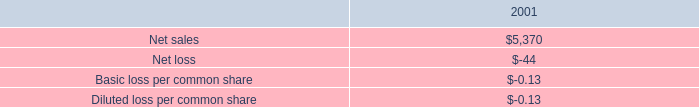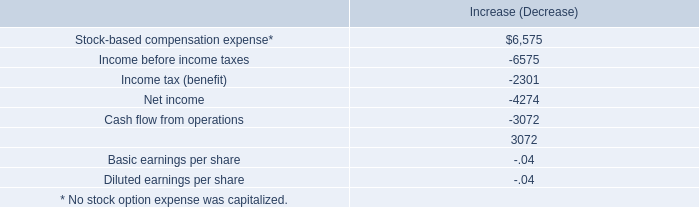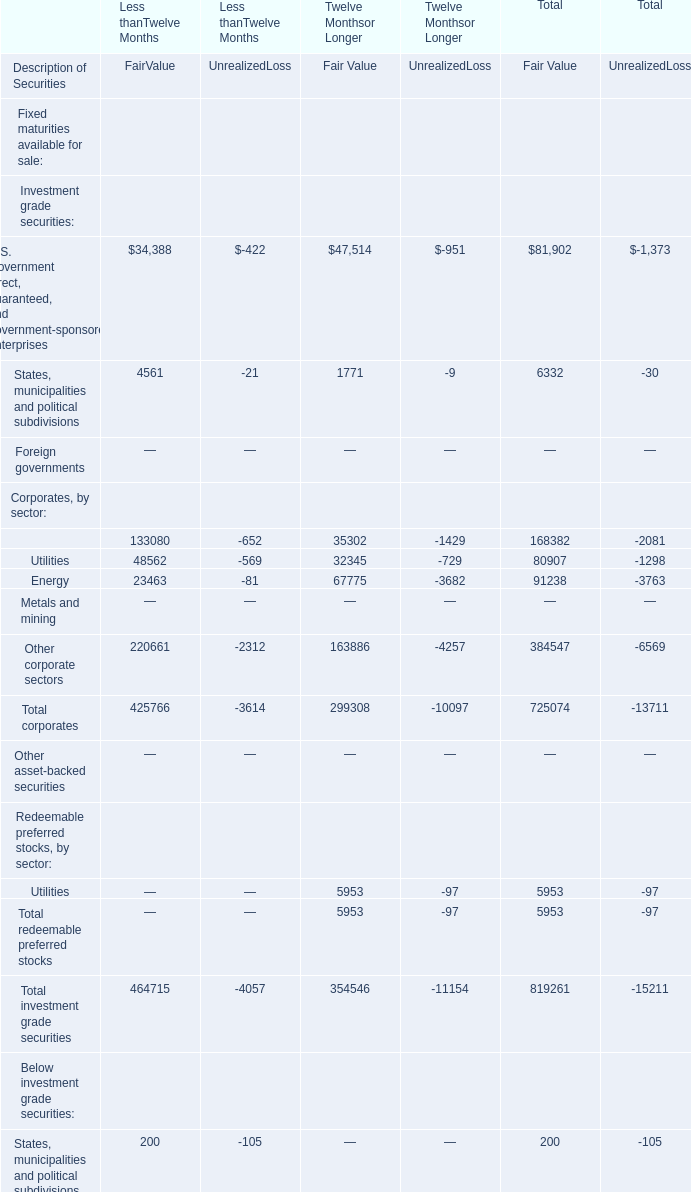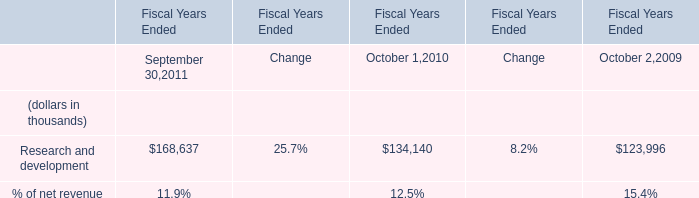what percentage of the total restructuring charges during the year ended september 27 , 2003 were severance costs? 
Computations: (7.4 / 26.8)
Answer: 0.27612. 